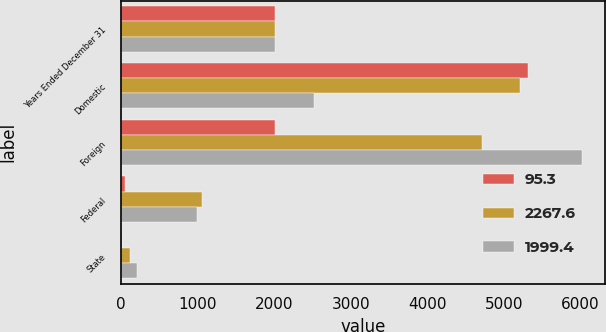Convert chart to OTSL. <chart><loc_0><loc_0><loc_500><loc_500><stacked_bar_chart><ecel><fcel>Years Ended December 31<fcel>Domestic<fcel>Foreign<fcel>Federal<fcel>State<nl><fcel>95.3<fcel>2009<fcel>5319.5<fcel>2007.5<fcel>55.2<fcel>7.2<nl><fcel>2267.6<fcel>2008<fcel>5210.1<fcel>4721.6<fcel>1053.6<fcel>123.3<nl><fcel>1999.4<fcel>2007<fcel>2525.8<fcel>6017.9<fcel>988.1<fcel>202.2<nl></chart> 